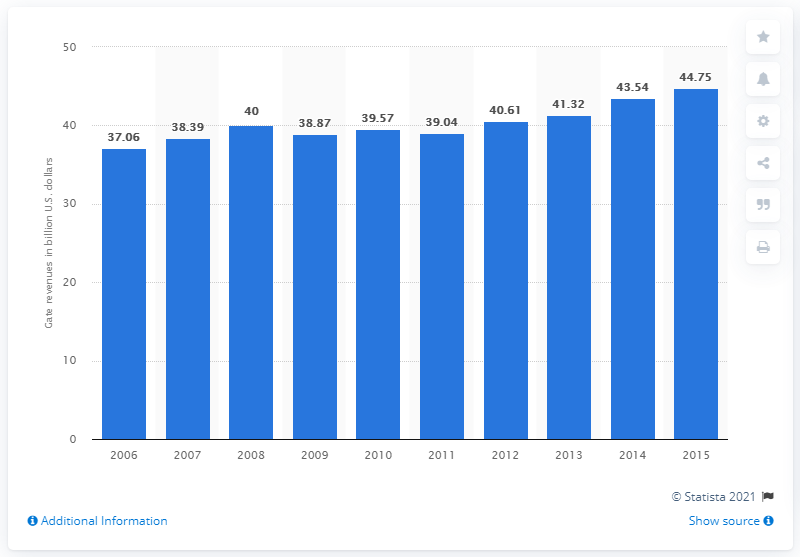List a handful of essential elements in this visual. In 2010, gate revenues generated a total of $39.57. 